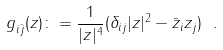Convert formula to latex. <formula><loc_0><loc_0><loc_500><loc_500>g _ { i \bar { j } } ( z ) \colon = \frac { 1 } { | z | ^ { 4 } } ( \delta _ { i j } | z | ^ { 2 } - \bar { z } _ { i } z _ { j } ) \ .</formula> 